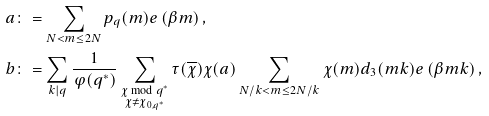Convert formula to latex. <formula><loc_0><loc_0><loc_500><loc_500>a & \colon = \sum _ { N < m \leq 2 N } p _ { q } ( m ) e \left ( \beta m \right ) , \\ b & \colon = \sum _ { k | q } \frac { 1 } { \varphi ( q ^ { * } ) } \sum _ { \substack { \chi \bmod { q ^ { * } } \\ \chi \not = \chi _ { 0 , q ^ { * } } } } \tau ( \overline { \chi } ) \chi ( a ) \sum _ { N / k < m \leq 2 N / k } \chi ( m ) d _ { 3 } ( m k ) e \left ( \beta m k \right ) ,</formula> 